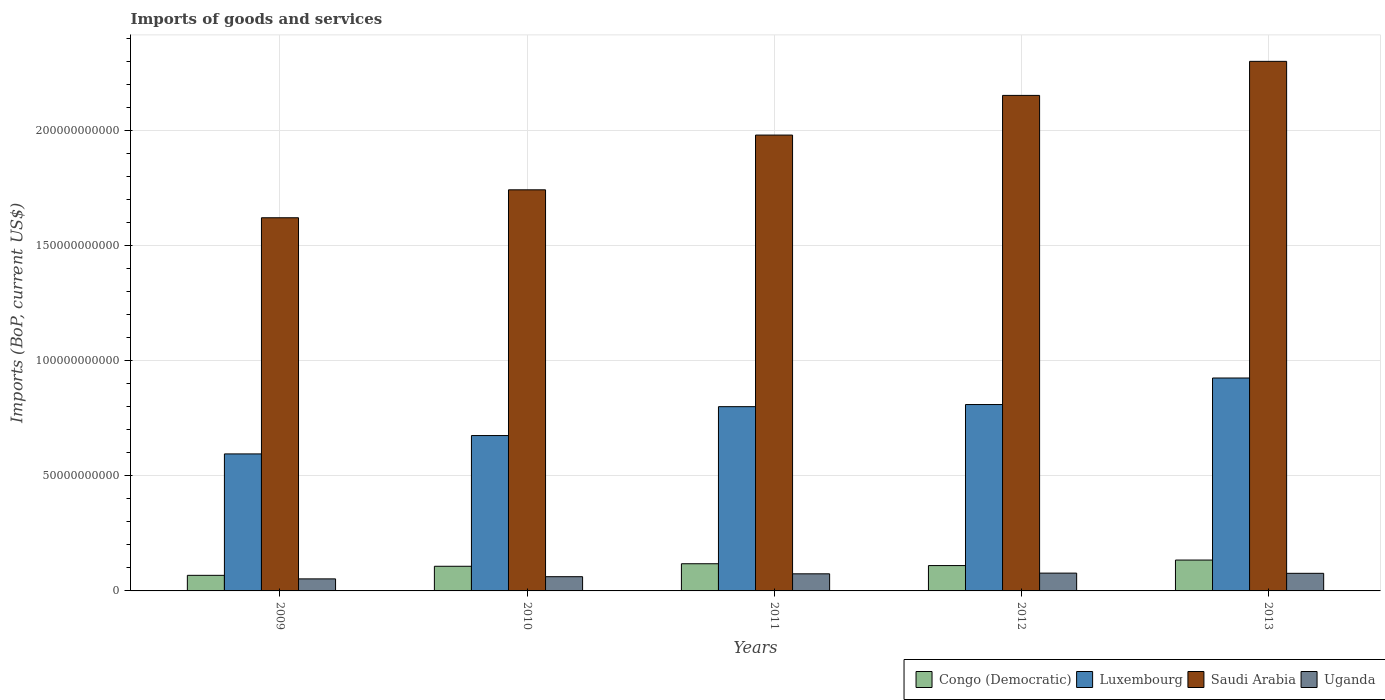How many different coloured bars are there?
Provide a succinct answer. 4. How many groups of bars are there?
Offer a very short reply. 5. How many bars are there on the 1st tick from the right?
Your response must be concise. 4. What is the label of the 3rd group of bars from the left?
Give a very brief answer. 2011. What is the amount spent on imports in Luxembourg in 2013?
Keep it short and to the point. 9.25e+1. Across all years, what is the maximum amount spent on imports in Congo (Democratic)?
Make the answer very short. 1.34e+1. Across all years, what is the minimum amount spent on imports in Luxembourg?
Your answer should be very brief. 5.95e+1. In which year was the amount spent on imports in Saudi Arabia maximum?
Make the answer very short. 2013. What is the total amount spent on imports in Uganda in the graph?
Provide a short and direct response. 3.42e+1. What is the difference between the amount spent on imports in Luxembourg in 2011 and that in 2012?
Your response must be concise. -9.28e+08. What is the difference between the amount spent on imports in Saudi Arabia in 2010 and the amount spent on imports in Uganda in 2012?
Make the answer very short. 1.66e+11. What is the average amount spent on imports in Uganda per year?
Give a very brief answer. 6.84e+09. In the year 2011, what is the difference between the amount spent on imports in Congo (Democratic) and amount spent on imports in Saudi Arabia?
Offer a very short reply. -1.86e+11. In how many years, is the amount spent on imports in Saudi Arabia greater than 30000000000 US$?
Offer a very short reply. 5. What is the ratio of the amount spent on imports in Uganda in 2010 to that in 2013?
Keep it short and to the point. 0.81. Is the amount spent on imports in Luxembourg in 2010 less than that in 2013?
Offer a very short reply. Yes. Is the difference between the amount spent on imports in Congo (Democratic) in 2011 and 2013 greater than the difference between the amount spent on imports in Saudi Arabia in 2011 and 2013?
Your answer should be very brief. Yes. What is the difference between the highest and the second highest amount spent on imports in Uganda?
Offer a very short reply. 9.31e+07. What is the difference between the highest and the lowest amount spent on imports in Uganda?
Your response must be concise. 2.51e+09. In how many years, is the amount spent on imports in Congo (Democratic) greater than the average amount spent on imports in Congo (Democratic) taken over all years?
Give a very brief answer. 3. Is it the case that in every year, the sum of the amount spent on imports in Saudi Arabia and amount spent on imports in Congo (Democratic) is greater than the sum of amount spent on imports in Luxembourg and amount spent on imports in Uganda?
Make the answer very short. No. What does the 2nd bar from the left in 2010 represents?
Offer a terse response. Luxembourg. What does the 1st bar from the right in 2013 represents?
Offer a very short reply. Uganda. Is it the case that in every year, the sum of the amount spent on imports in Luxembourg and amount spent on imports in Congo (Democratic) is greater than the amount spent on imports in Uganda?
Your answer should be compact. Yes. How many bars are there?
Keep it short and to the point. 20. How many years are there in the graph?
Offer a terse response. 5. Are the values on the major ticks of Y-axis written in scientific E-notation?
Provide a succinct answer. No. Does the graph contain any zero values?
Ensure brevity in your answer.  No. Where does the legend appear in the graph?
Offer a terse response. Bottom right. How many legend labels are there?
Offer a very short reply. 4. How are the legend labels stacked?
Provide a short and direct response. Horizontal. What is the title of the graph?
Make the answer very short. Imports of goods and services. What is the label or title of the X-axis?
Ensure brevity in your answer.  Years. What is the label or title of the Y-axis?
Offer a very short reply. Imports (BoP, current US$). What is the Imports (BoP, current US$) in Congo (Democratic) in 2009?
Your response must be concise. 6.77e+09. What is the Imports (BoP, current US$) in Luxembourg in 2009?
Make the answer very short. 5.95e+1. What is the Imports (BoP, current US$) of Saudi Arabia in 2009?
Offer a terse response. 1.62e+11. What is the Imports (BoP, current US$) of Uganda in 2009?
Your answer should be compact. 5.23e+09. What is the Imports (BoP, current US$) in Congo (Democratic) in 2010?
Offer a terse response. 1.07e+1. What is the Imports (BoP, current US$) in Luxembourg in 2010?
Your response must be concise. 6.75e+1. What is the Imports (BoP, current US$) of Saudi Arabia in 2010?
Make the answer very short. 1.74e+11. What is the Imports (BoP, current US$) of Uganda in 2010?
Ensure brevity in your answer.  6.18e+09. What is the Imports (BoP, current US$) in Congo (Democratic) in 2011?
Give a very brief answer. 1.18e+1. What is the Imports (BoP, current US$) in Luxembourg in 2011?
Provide a short and direct response. 8.00e+1. What is the Imports (BoP, current US$) in Saudi Arabia in 2011?
Ensure brevity in your answer.  1.98e+11. What is the Imports (BoP, current US$) in Uganda in 2011?
Your answer should be very brief. 7.43e+09. What is the Imports (BoP, current US$) of Congo (Democratic) in 2012?
Your response must be concise. 1.10e+1. What is the Imports (BoP, current US$) of Luxembourg in 2012?
Provide a short and direct response. 8.09e+1. What is the Imports (BoP, current US$) in Saudi Arabia in 2012?
Offer a terse response. 2.15e+11. What is the Imports (BoP, current US$) in Uganda in 2012?
Make the answer very short. 7.74e+09. What is the Imports (BoP, current US$) in Congo (Democratic) in 2013?
Give a very brief answer. 1.34e+1. What is the Imports (BoP, current US$) of Luxembourg in 2013?
Your answer should be compact. 9.25e+1. What is the Imports (BoP, current US$) in Saudi Arabia in 2013?
Offer a very short reply. 2.30e+11. What is the Imports (BoP, current US$) in Uganda in 2013?
Offer a terse response. 7.64e+09. Across all years, what is the maximum Imports (BoP, current US$) in Congo (Democratic)?
Ensure brevity in your answer.  1.34e+1. Across all years, what is the maximum Imports (BoP, current US$) of Luxembourg?
Give a very brief answer. 9.25e+1. Across all years, what is the maximum Imports (BoP, current US$) in Saudi Arabia?
Your response must be concise. 2.30e+11. Across all years, what is the maximum Imports (BoP, current US$) in Uganda?
Keep it short and to the point. 7.74e+09. Across all years, what is the minimum Imports (BoP, current US$) in Congo (Democratic)?
Give a very brief answer. 6.77e+09. Across all years, what is the minimum Imports (BoP, current US$) of Luxembourg?
Offer a terse response. 5.95e+1. Across all years, what is the minimum Imports (BoP, current US$) of Saudi Arabia?
Provide a succinct answer. 1.62e+11. Across all years, what is the minimum Imports (BoP, current US$) in Uganda?
Provide a short and direct response. 5.23e+09. What is the total Imports (BoP, current US$) in Congo (Democratic) in the graph?
Your response must be concise. 5.37e+1. What is the total Imports (BoP, current US$) in Luxembourg in the graph?
Your response must be concise. 3.80e+11. What is the total Imports (BoP, current US$) in Saudi Arabia in the graph?
Give a very brief answer. 9.79e+11. What is the total Imports (BoP, current US$) in Uganda in the graph?
Your answer should be very brief. 3.42e+1. What is the difference between the Imports (BoP, current US$) in Congo (Democratic) in 2009 and that in 2010?
Your answer should be very brief. -3.94e+09. What is the difference between the Imports (BoP, current US$) in Luxembourg in 2009 and that in 2010?
Your answer should be compact. -7.98e+09. What is the difference between the Imports (BoP, current US$) in Saudi Arabia in 2009 and that in 2010?
Your answer should be very brief. -1.21e+1. What is the difference between the Imports (BoP, current US$) of Uganda in 2009 and that in 2010?
Your answer should be compact. -9.50e+08. What is the difference between the Imports (BoP, current US$) in Congo (Democratic) in 2009 and that in 2011?
Your response must be concise. -5.04e+09. What is the difference between the Imports (BoP, current US$) of Luxembourg in 2009 and that in 2011?
Keep it short and to the point. -2.05e+1. What is the difference between the Imports (BoP, current US$) in Saudi Arabia in 2009 and that in 2011?
Your answer should be very brief. -3.59e+1. What is the difference between the Imports (BoP, current US$) in Uganda in 2009 and that in 2011?
Your answer should be compact. -2.20e+09. What is the difference between the Imports (BoP, current US$) of Congo (Democratic) in 2009 and that in 2012?
Provide a succinct answer. -4.24e+09. What is the difference between the Imports (BoP, current US$) of Luxembourg in 2009 and that in 2012?
Your answer should be very brief. -2.14e+1. What is the difference between the Imports (BoP, current US$) of Saudi Arabia in 2009 and that in 2012?
Offer a very short reply. -5.31e+1. What is the difference between the Imports (BoP, current US$) in Uganda in 2009 and that in 2012?
Provide a succinct answer. -2.51e+09. What is the difference between the Imports (BoP, current US$) in Congo (Democratic) in 2009 and that in 2013?
Provide a succinct answer. -6.64e+09. What is the difference between the Imports (BoP, current US$) of Luxembourg in 2009 and that in 2013?
Keep it short and to the point. -3.30e+1. What is the difference between the Imports (BoP, current US$) in Saudi Arabia in 2009 and that in 2013?
Make the answer very short. -6.79e+1. What is the difference between the Imports (BoP, current US$) in Uganda in 2009 and that in 2013?
Keep it short and to the point. -2.41e+09. What is the difference between the Imports (BoP, current US$) of Congo (Democratic) in 2010 and that in 2011?
Make the answer very short. -1.10e+09. What is the difference between the Imports (BoP, current US$) in Luxembourg in 2010 and that in 2011?
Provide a succinct answer. -1.25e+1. What is the difference between the Imports (BoP, current US$) in Saudi Arabia in 2010 and that in 2011?
Keep it short and to the point. -2.38e+1. What is the difference between the Imports (BoP, current US$) in Uganda in 2010 and that in 2011?
Give a very brief answer. -1.25e+09. What is the difference between the Imports (BoP, current US$) of Congo (Democratic) in 2010 and that in 2012?
Your answer should be compact. -3.04e+08. What is the difference between the Imports (BoP, current US$) of Luxembourg in 2010 and that in 2012?
Make the answer very short. -1.35e+1. What is the difference between the Imports (BoP, current US$) of Saudi Arabia in 2010 and that in 2012?
Keep it short and to the point. -4.10e+1. What is the difference between the Imports (BoP, current US$) in Uganda in 2010 and that in 2012?
Offer a very short reply. -1.56e+09. What is the difference between the Imports (BoP, current US$) in Congo (Democratic) in 2010 and that in 2013?
Keep it short and to the point. -2.70e+09. What is the difference between the Imports (BoP, current US$) of Luxembourg in 2010 and that in 2013?
Your response must be concise. -2.50e+1. What is the difference between the Imports (BoP, current US$) of Saudi Arabia in 2010 and that in 2013?
Give a very brief answer. -5.58e+1. What is the difference between the Imports (BoP, current US$) in Uganda in 2010 and that in 2013?
Your answer should be very brief. -1.46e+09. What is the difference between the Imports (BoP, current US$) of Congo (Democratic) in 2011 and that in 2012?
Provide a short and direct response. 7.96e+08. What is the difference between the Imports (BoP, current US$) of Luxembourg in 2011 and that in 2012?
Offer a terse response. -9.28e+08. What is the difference between the Imports (BoP, current US$) in Saudi Arabia in 2011 and that in 2012?
Provide a short and direct response. -1.72e+1. What is the difference between the Imports (BoP, current US$) of Uganda in 2011 and that in 2012?
Offer a very short reply. -3.05e+08. What is the difference between the Imports (BoP, current US$) in Congo (Democratic) in 2011 and that in 2013?
Give a very brief answer. -1.60e+09. What is the difference between the Imports (BoP, current US$) of Luxembourg in 2011 and that in 2013?
Ensure brevity in your answer.  -1.24e+1. What is the difference between the Imports (BoP, current US$) of Saudi Arabia in 2011 and that in 2013?
Ensure brevity in your answer.  -3.20e+1. What is the difference between the Imports (BoP, current US$) in Uganda in 2011 and that in 2013?
Offer a terse response. -2.12e+08. What is the difference between the Imports (BoP, current US$) of Congo (Democratic) in 2012 and that in 2013?
Your answer should be compact. -2.39e+09. What is the difference between the Imports (BoP, current US$) in Luxembourg in 2012 and that in 2013?
Your response must be concise. -1.15e+1. What is the difference between the Imports (BoP, current US$) of Saudi Arabia in 2012 and that in 2013?
Give a very brief answer. -1.48e+1. What is the difference between the Imports (BoP, current US$) in Uganda in 2012 and that in 2013?
Offer a very short reply. 9.31e+07. What is the difference between the Imports (BoP, current US$) of Congo (Democratic) in 2009 and the Imports (BoP, current US$) of Luxembourg in 2010?
Ensure brevity in your answer.  -6.07e+1. What is the difference between the Imports (BoP, current US$) of Congo (Democratic) in 2009 and the Imports (BoP, current US$) of Saudi Arabia in 2010?
Ensure brevity in your answer.  -1.67e+11. What is the difference between the Imports (BoP, current US$) in Congo (Democratic) in 2009 and the Imports (BoP, current US$) in Uganda in 2010?
Offer a terse response. 5.88e+08. What is the difference between the Imports (BoP, current US$) of Luxembourg in 2009 and the Imports (BoP, current US$) of Saudi Arabia in 2010?
Keep it short and to the point. -1.15e+11. What is the difference between the Imports (BoP, current US$) of Luxembourg in 2009 and the Imports (BoP, current US$) of Uganda in 2010?
Ensure brevity in your answer.  5.33e+1. What is the difference between the Imports (BoP, current US$) of Saudi Arabia in 2009 and the Imports (BoP, current US$) of Uganda in 2010?
Your response must be concise. 1.56e+11. What is the difference between the Imports (BoP, current US$) in Congo (Democratic) in 2009 and the Imports (BoP, current US$) in Luxembourg in 2011?
Your answer should be compact. -7.33e+1. What is the difference between the Imports (BoP, current US$) in Congo (Democratic) in 2009 and the Imports (BoP, current US$) in Saudi Arabia in 2011?
Offer a very short reply. -1.91e+11. What is the difference between the Imports (BoP, current US$) in Congo (Democratic) in 2009 and the Imports (BoP, current US$) in Uganda in 2011?
Offer a terse response. -6.64e+08. What is the difference between the Imports (BoP, current US$) in Luxembourg in 2009 and the Imports (BoP, current US$) in Saudi Arabia in 2011?
Offer a terse response. -1.38e+11. What is the difference between the Imports (BoP, current US$) of Luxembourg in 2009 and the Imports (BoP, current US$) of Uganda in 2011?
Your answer should be very brief. 5.21e+1. What is the difference between the Imports (BoP, current US$) of Saudi Arabia in 2009 and the Imports (BoP, current US$) of Uganda in 2011?
Ensure brevity in your answer.  1.55e+11. What is the difference between the Imports (BoP, current US$) in Congo (Democratic) in 2009 and the Imports (BoP, current US$) in Luxembourg in 2012?
Offer a terse response. -7.42e+1. What is the difference between the Imports (BoP, current US$) in Congo (Democratic) in 2009 and the Imports (BoP, current US$) in Saudi Arabia in 2012?
Your answer should be compact. -2.08e+11. What is the difference between the Imports (BoP, current US$) in Congo (Democratic) in 2009 and the Imports (BoP, current US$) in Uganda in 2012?
Provide a succinct answer. -9.69e+08. What is the difference between the Imports (BoP, current US$) in Luxembourg in 2009 and the Imports (BoP, current US$) in Saudi Arabia in 2012?
Your answer should be compact. -1.56e+11. What is the difference between the Imports (BoP, current US$) of Luxembourg in 2009 and the Imports (BoP, current US$) of Uganda in 2012?
Your response must be concise. 5.18e+1. What is the difference between the Imports (BoP, current US$) of Saudi Arabia in 2009 and the Imports (BoP, current US$) of Uganda in 2012?
Make the answer very short. 1.54e+11. What is the difference between the Imports (BoP, current US$) in Congo (Democratic) in 2009 and the Imports (BoP, current US$) in Luxembourg in 2013?
Make the answer very short. -8.57e+1. What is the difference between the Imports (BoP, current US$) of Congo (Democratic) in 2009 and the Imports (BoP, current US$) of Saudi Arabia in 2013?
Give a very brief answer. -2.23e+11. What is the difference between the Imports (BoP, current US$) in Congo (Democratic) in 2009 and the Imports (BoP, current US$) in Uganda in 2013?
Your response must be concise. -8.76e+08. What is the difference between the Imports (BoP, current US$) in Luxembourg in 2009 and the Imports (BoP, current US$) in Saudi Arabia in 2013?
Give a very brief answer. -1.70e+11. What is the difference between the Imports (BoP, current US$) of Luxembourg in 2009 and the Imports (BoP, current US$) of Uganda in 2013?
Your response must be concise. 5.19e+1. What is the difference between the Imports (BoP, current US$) of Saudi Arabia in 2009 and the Imports (BoP, current US$) of Uganda in 2013?
Offer a terse response. 1.54e+11. What is the difference between the Imports (BoP, current US$) of Congo (Democratic) in 2010 and the Imports (BoP, current US$) of Luxembourg in 2011?
Make the answer very short. -6.93e+1. What is the difference between the Imports (BoP, current US$) of Congo (Democratic) in 2010 and the Imports (BoP, current US$) of Saudi Arabia in 2011?
Make the answer very short. -1.87e+11. What is the difference between the Imports (BoP, current US$) of Congo (Democratic) in 2010 and the Imports (BoP, current US$) of Uganda in 2011?
Keep it short and to the point. 3.27e+09. What is the difference between the Imports (BoP, current US$) of Luxembourg in 2010 and the Imports (BoP, current US$) of Saudi Arabia in 2011?
Your answer should be very brief. -1.31e+11. What is the difference between the Imports (BoP, current US$) of Luxembourg in 2010 and the Imports (BoP, current US$) of Uganda in 2011?
Ensure brevity in your answer.  6.00e+1. What is the difference between the Imports (BoP, current US$) in Saudi Arabia in 2010 and the Imports (BoP, current US$) in Uganda in 2011?
Your response must be concise. 1.67e+11. What is the difference between the Imports (BoP, current US$) in Congo (Democratic) in 2010 and the Imports (BoP, current US$) in Luxembourg in 2012?
Your answer should be very brief. -7.02e+1. What is the difference between the Imports (BoP, current US$) of Congo (Democratic) in 2010 and the Imports (BoP, current US$) of Saudi Arabia in 2012?
Make the answer very short. -2.05e+11. What is the difference between the Imports (BoP, current US$) in Congo (Democratic) in 2010 and the Imports (BoP, current US$) in Uganda in 2012?
Your answer should be very brief. 2.97e+09. What is the difference between the Imports (BoP, current US$) of Luxembourg in 2010 and the Imports (BoP, current US$) of Saudi Arabia in 2012?
Provide a succinct answer. -1.48e+11. What is the difference between the Imports (BoP, current US$) of Luxembourg in 2010 and the Imports (BoP, current US$) of Uganda in 2012?
Provide a short and direct response. 5.97e+1. What is the difference between the Imports (BoP, current US$) in Saudi Arabia in 2010 and the Imports (BoP, current US$) in Uganda in 2012?
Provide a succinct answer. 1.66e+11. What is the difference between the Imports (BoP, current US$) in Congo (Democratic) in 2010 and the Imports (BoP, current US$) in Luxembourg in 2013?
Your answer should be compact. -8.18e+1. What is the difference between the Imports (BoP, current US$) of Congo (Democratic) in 2010 and the Imports (BoP, current US$) of Saudi Arabia in 2013?
Keep it short and to the point. -2.19e+11. What is the difference between the Imports (BoP, current US$) in Congo (Democratic) in 2010 and the Imports (BoP, current US$) in Uganda in 2013?
Ensure brevity in your answer.  3.06e+09. What is the difference between the Imports (BoP, current US$) of Luxembourg in 2010 and the Imports (BoP, current US$) of Saudi Arabia in 2013?
Your answer should be compact. -1.63e+11. What is the difference between the Imports (BoP, current US$) of Luxembourg in 2010 and the Imports (BoP, current US$) of Uganda in 2013?
Offer a terse response. 5.98e+1. What is the difference between the Imports (BoP, current US$) in Saudi Arabia in 2010 and the Imports (BoP, current US$) in Uganda in 2013?
Offer a very short reply. 1.67e+11. What is the difference between the Imports (BoP, current US$) in Congo (Democratic) in 2011 and the Imports (BoP, current US$) in Luxembourg in 2012?
Your answer should be compact. -6.91e+1. What is the difference between the Imports (BoP, current US$) of Congo (Democratic) in 2011 and the Imports (BoP, current US$) of Saudi Arabia in 2012?
Your answer should be very brief. -2.03e+11. What is the difference between the Imports (BoP, current US$) in Congo (Democratic) in 2011 and the Imports (BoP, current US$) in Uganda in 2012?
Keep it short and to the point. 4.07e+09. What is the difference between the Imports (BoP, current US$) of Luxembourg in 2011 and the Imports (BoP, current US$) of Saudi Arabia in 2012?
Your response must be concise. -1.35e+11. What is the difference between the Imports (BoP, current US$) in Luxembourg in 2011 and the Imports (BoP, current US$) in Uganda in 2012?
Ensure brevity in your answer.  7.23e+1. What is the difference between the Imports (BoP, current US$) of Saudi Arabia in 2011 and the Imports (BoP, current US$) of Uganda in 2012?
Provide a short and direct response. 1.90e+11. What is the difference between the Imports (BoP, current US$) in Congo (Democratic) in 2011 and the Imports (BoP, current US$) in Luxembourg in 2013?
Make the answer very short. -8.07e+1. What is the difference between the Imports (BoP, current US$) in Congo (Democratic) in 2011 and the Imports (BoP, current US$) in Saudi Arabia in 2013?
Provide a short and direct response. -2.18e+11. What is the difference between the Imports (BoP, current US$) in Congo (Democratic) in 2011 and the Imports (BoP, current US$) in Uganda in 2013?
Offer a very short reply. 4.16e+09. What is the difference between the Imports (BoP, current US$) of Luxembourg in 2011 and the Imports (BoP, current US$) of Saudi Arabia in 2013?
Provide a succinct answer. -1.50e+11. What is the difference between the Imports (BoP, current US$) in Luxembourg in 2011 and the Imports (BoP, current US$) in Uganda in 2013?
Provide a short and direct response. 7.24e+1. What is the difference between the Imports (BoP, current US$) of Saudi Arabia in 2011 and the Imports (BoP, current US$) of Uganda in 2013?
Your answer should be compact. 1.90e+11. What is the difference between the Imports (BoP, current US$) in Congo (Democratic) in 2012 and the Imports (BoP, current US$) in Luxembourg in 2013?
Ensure brevity in your answer.  -8.15e+1. What is the difference between the Imports (BoP, current US$) of Congo (Democratic) in 2012 and the Imports (BoP, current US$) of Saudi Arabia in 2013?
Your answer should be compact. -2.19e+11. What is the difference between the Imports (BoP, current US$) in Congo (Democratic) in 2012 and the Imports (BoP, current US$) in Uganda in 2013?
Your answer should be compact. 3.37e+09. What is the difference between the Imports (BoP, current US$) in Luxembourg in 2012 and the Imports (BoP, current US$) in Saudi Arabia in 2013?
Keep it short and to the point. -1.49e+11. What is the difference between the Imports (BoP, current US$) in Luxembourg in 2012 and the Imports (BoP, current US$) in Uganda in 2013?
Give a very brief answer. 7.33e+1. What is the difference between the Imports (BoP, current US$) in Saudi Arabia in 2012 and the Imports (BoP, current US$) in Uganda in 2013?
Make the answer very short. 2.08e+11. What is the average Imports (BoP, current US$) of Congo (Democratic) per year?
Give a very brief answer. 1.07e+1. What is the average Imports (BoP, current US$) in Luxembourg per year?
Your answer should be very brief. 7.61e+1. What is the average Imports (BoP, current US$) in Saudi Arabia per year?
Make the answer very short. 1.96e+11. What is the average Imports (BoP, current US$) of Uganda per year?
Make the answer very short. 6.84e+09. In the year 2009, what is the difference between the Imports (BoP, current US$) in Congo (Democratic) and Imports (BoP, current US$) in Luxembourg?
Ensure brevity in your answer.  -5.27e+1. In the year 2009, what is the difference between the Imports (BoP, current US$) in Congo (Democratic) and Imports (BoP, current US$) in Saudi Arabia?
Provide a succinct answer. -1.55e+11. In the year 2009, what is the difference between the Imports (BoP, current US$) of Congo (Democratic) and Imports (BoP, current US$) of Uganda?
Your answer should be very brief. 1.54e+09. In the year 2009, what is the difference between the Imports (BoP, current US$) of Luxembourg and Imports (BoP, current US$) of Saudi Arabia?
Give a very brief answer. -1.03e+11. In the year 2009, what is the difference between the Imports (BoP, current US$) in Luxembourg and Imports (BoP, current US$) in Uganda?
Offer a terse response. 5.43e+1. In the year 2009, what is the difference between the Imports (BoP, current US$) of Saudi Arabia and Imports (BoP, current US$) of Uganda?
Ensure brevity in your answer.  1.57e+11. In the year 2010, what is the difference between the Imports (BoP, current US$) in Congo (Democratic) and Imports (BoP, current US$) in Luxembourg?
Ensure brevity in your answer.  -5.68e+1. In the year 2010, what is the difference between the Imports (BoP, current US$) of Congo (Democratic) and Imports (BoP, current US$) of Saudi Arabia?
Provide a short and direct response. -1.63e+11. In the year 2010, what is the difference between the Imports (BoP, current US$) of Congo (Democratic) and Imports (BoP, current US$) of Uganda?
Keep it short and to the point. 4.53e+09. In the year 2010, what is the difference between the Imports (BoP, current US$) of Luxembourg and Imports (BoP, current US$) of Saudi Arabia?
Your answer should be compact. -1.07e+11. In the year 2010, what is the difference between the Imports (BoP, current US$) of Luxembourg and Imports (BoP, current US$) of Uganda?
Keep it short and to the point. 6.13e+1. In the year 2010, what is the difference between the Imports (BoP, current US$) of Saudi Arabia and Imports (BoP, current US$) of Uganda?
Keep it short and to the point. 1.68e+11. In the year 2011, what is the difference between the Imports (BoP, current US$) of Congo (Democratic) and Imports (BoP, current US$) of Luxembourg?
Your response must be concise. -6.82e+1. In the year 2011, what is the difference between the Imports (BoP, current US$) of Congo (Democratic) and Imports (BoP, current US$) of Saudi Arabia?
Offer a very short reply. -1.86e+11. In the year 2011, what is the difference between the Imports (BoP, current US$) of Congo (Democratic) and Imports (BoP, current US$) of Uganda?
Keep it short and to the point. 4.37e+09. In the year 2011, what is the difference between the Imports (BoP, current US$) in Luxembourg and Imports (BoP, current US$) in Saudi Arabia?
Your response must be concise. -1.18e+11. In the year 2011, what is the difference between the Imports (BoP, current US$) in Luxembourg and Imports (BoP, current US$) in Uganda?
Make the answer very short. 7.26e+1. In the year 2011, what is the difference between the Imports (BoP, current US$) in Saudi Arabia and Imports (BoP, current US$) in Uganda?
Your answer should be very brief. 1.91e+11. In the year 2012, what is the difference between the Imports (BoP, current US$) in Congo (Democratic) and Imports (BoP, current US$) in Luxembourg?
Offer a terse response. -6.99e+1. In the year 2012, what is the difference between the Imports (BoP, current US$) in Congo (Democratic) and Imports (BoP, current US$) in Saudi Arabia?
Your answer should be very brief. -2.04e+11. In the year 2012, what is the difference between the Imports (BoP, current US$) of Congo (Democratic) and Imports (BoP, current US$) of Uganda?
Offer a terse response. 3.27e+09. In the year 2012, what is the difference between the Imports (BoP, current US$) of Luxembourg and Imports (BoP, current US$) of Saudi Arabia?
Offer a terse response. -1.34e+11. In the year 2012, what is the difference between the Imports (BoP, current US$) of Luxembourg and Imports (BoP, current US$) of Uganda?
Provide a succinct answer. 7.32e+1. In the year 2012, what is the difference between the Imports (BoP, current US$) of Saudi Arabia and Imports (BoP, current US$) of Uganda?
Your answer should be very brief. 2.07e+11. In the year 2013, what is the difference between the Imports (BoP, current US$) in Congo (Democratic) and Imports (BoP, current US$) in Luxembourg?
Your answer should be compact. -7.91e+1. In the year 2013, what is the difference between the Imports (BoP, current US$) in Congo (Democratic) and Imports (BoP, current US$) in Saudi Arabia?
Your answer should be very brief. -2.17e+11. In the year 2013, what is the difference between the Imports (BoP, current US$) in Congo (Democratic) and Imports (BoP, current US$) in Uganda?
Provide a succinct answer. 5.76e+09. In the year 2013, what is the difference between the Imports (BoP, current US$) in Luxembourg and Imports (BoP, current US$) in Saudi Arabia?
Make the answer very short. -1.38e+11. In the year 2013, what is the difference between the Imports (BoP, current US$) of Luxembourg and Imports (BoP, current US$) of Uganda?
Make the answer very short. 8.48e+1. In the year 2013, what is the difference between the Imports (BoP, current US$) of Saudi Arabia and Imports (BoP, current US$) of Uganda?
Your response must be concise. 2.22e+11. What is the ratio of the Imports (BoP, current US$) in Congo (Democratic) in 2009 to that in 2010?
Make the answer very short. 0.63. What is the ratio of the Imports (BoP, current US$) in Luxembourg in 2009 to that in 2010?
Offer a very short reply. 0.88. What is the ratio of the Imports (BoP, current US$) of Saudi Arabia in 2009 to that in 2010?
Provide a succinct answer. 0.93. What is the ratio of the Imports (BoP, current US$) of Uganda in 2009 to that in 2010?
Your answer should be compact. 0.85. What is the ratio of the Imports (BoP, current US$) of Congo (Democratic) in 2009 to that in 2011?
Make the answer very short. 0.57. What is the ratio of the Imports (BoP, current US$) of Luxembourg in 2009 to that in 2011?
Your answer should be compact. 0.74. What is the ratio of the Imports (BoP, current US$) of Saudi Arabia in 2009 to that in 2011?
Provide a short and direct response. 0.82. What is the ratio of the Imports (BoP, current US$) in Uganda in 2009 to that in 2011?
Make the answer very short. 0.7. What is the ratio of the Imports (BoP, current US$) of Congo (Democratic) in 2009 to that in 2012?
Offer a very short reply. 0.61. What is the ratio of the Imports (BoP, current US$) in Luxembourg in 2009 to that in 2012?
Your response must be concise. 0.73. What is the ratio of the Imports (BoP, current US$) in Saudi Arabia in 2009 to that in 2012?
Provide a short and direct response. 0.75. What is the ratio of the Imports (BoP, current US$) in Uganda in 2009 to that in 2012?
Offer a terse response. 0.68. What is the ratio of the Imports (BoP, current US$) of Congo (Democratic) in 2009 to that in 2013?
Make the answer very short. 0.5. What is the ratio of the Imports (BoP, current US$) in Luxembourg in 2009 to that in 2013?
Offer a very short reply. 0.64. What is the ratio of the Imports (BoP, current US$) of Saudi Arabia in 2009 to that in 2013?
Make the answer very short. 0.7. What is the ratio of the Imports (BoP, current US$) in Uganda in 2009 to that in 2013?
Your response must be concise. 0.68. What is the ratio of the Imports (BoP, current US$) in Congo (Democratic) in 2010 to that in 2011?
Make the answer very short. 0.91. What is the ratio of the Imports (BoP, current US$) of Luxembourg in 2010 to that in 2011?
Your response must be concise. 0.84. What is the ratio of the Imports (BoP, current US$) of Saudi Arabia in 2010 to that in 2011?
Your answer should be compact. 0.88. What is the ratio of the Imports (BoP, current US$) in Uganda in 2010 to that in 2011?
Your answer should be very brief. 0.83. What is the ratio of the Imports (BoP, current US$) of Congo (Democratic) in 2010 to that in 2012?
Keep it short and to the point. 0.97. What is the ratio of the Imports (BoP, current US$) in Luxembourg in 2010 to that in 2012?
Your answer should be compact. 0.83. What is the ratio of the Imports (BoP, current US$) of Saudi Arabia in 2010 to that in 2012?
Your answer should be very brief. 0.81. What is the ratio of the Imports (BoP, current US$) in Uganda in 2010 to that in 2012?
Provide a succinct answer. 0.8. What is the ratio of the Imports (BoP, current US$) of Congo (Democratic) in 2010 to that in 2013?
Your response must be concise. 0.8. What is the ratio of the Imports (BoP, current US$) of Luxembourg in 2010 to that in 2013?
Ensure brevity in your answer.  0.73. What is the ratio of the Imports (BoP, current US$) of Saudi Arabia in 2010 to that in 2013?
Offer a terse response. 0.76. What is the ratio of the Imports (BoP, current US$) of Uganda in 2010 to that in 2013?
Provide a succinct answer. 0.81. What is the ratio of the Imports (BoP, current US$) of Congo (Democratic) in 2011 to that in 2012?
Offer a terse response. 1.07. What is the ratio of the Imports (BoP, current US$) of Luxembourg in 2011 to that in 2012?
Keep it short and to the point. 0.99. What is the ratio of the Imports (BoP, current US$) of Saudi Arabia in 2011 to that in 2012?
Your response must be concise. 0.92. What is the ratio of the Imports (BoP, current US$) in Uganda in 2011 to that in 2012?
Offer a terse response. 0.96. What is the ratio of the Imports (BoP, current US$) of Congo (Democratic) in 2011 to that in 2013?
Provide a short and direct response. 0.88. What is the ratio of the Imports (BoP, current US$) in Luxembourg in 2011 to that in 2013?
Provide a succinct answer. 0.87. What is the ratio of the Imports (BoP, current US$) in Saudi Arabia in 2011 to that in 2013?
Give a very brief answer. 0.86. What is the ratio of the Imports (BoP, current US$) of Uganda in 2011 to that in 2013?
Ensure brevity in your answer.  0.97. What is the ratio of the Imports (BoP, current US$) in Congo (Democratic) in 2012 to that in 2013?
Keep it short and to the point. 0.82. What is the ratio of the Imports (BoP, current US$) in Luxembourg in 2012 to that in 2013?
Your response must be concise. 0.88. What is the ratio of the Imports (BoP, current US$) in Saudi Arabia in 2012 to that in 2013?
Your response must be concise. 0.94. What is the ratio of the Imports (BoP, current US$) of Uganda in 2012 to that in 2013?
Offer a very short reply. 1.01. What is the difference between the highest and the second highest Imports (BoP, current US$) of Congo (Democratic)?
Provide a short and direct response. 1.60e+09. What is the difference between the highest and the second highest Imports (BoP, current US$) in Luxembourg?
Keep it short and to the point. 1.15e+1. What is the difference between the highest and the second highest Imports (BoP, current US$) in Saudi Arabia?
Make the answer very short. 1.48e+1. What is the difference between the highest and the second highest Imports (BoP, current US$) in Uganda?
Your answer should be compact. 9.31e+07. What is the difference between the highest and the lowest Imports (BoP, current US$) of Congo (Democratic)?
Offer a very short reply. 6.64e+09. What is the difference between the highest and the lowest Imports (BoP, current US$) in Luxembourg?
Ensure brevity in your answer.  3.30e+1. What is the difference between the highest and the lowest Imports (BoP, current US$) in Saudi Arabia?
Your response must be concise. 6.79e+1. What is the difference between the highest and the lowest Imports (BoP, current US$) of Uganda?
Offer a very short reply. 2.51e+09. 